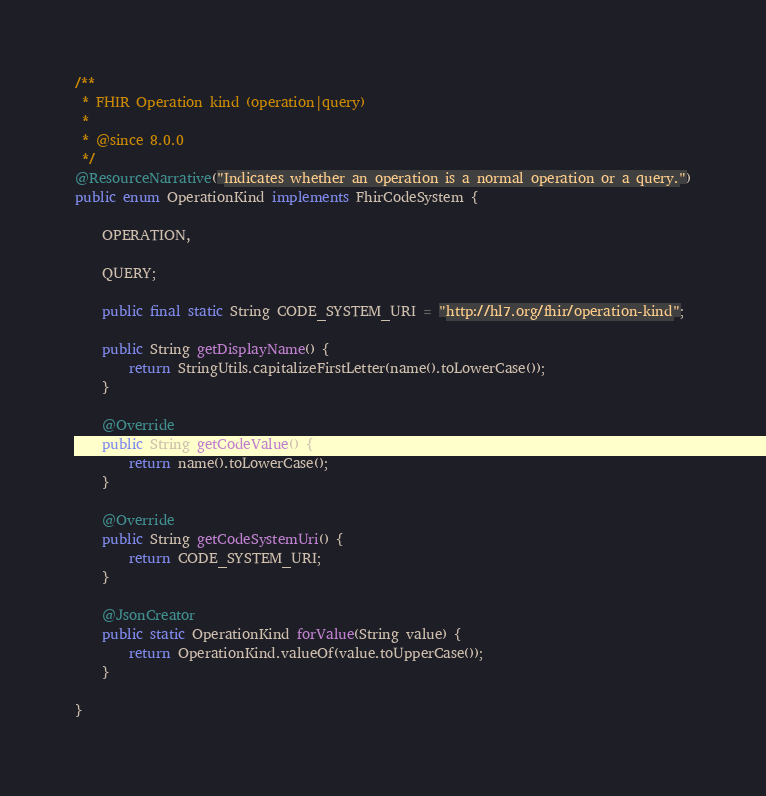Convert code to text. <code><loc_0><loc_0><loc_500><loc_500><_Java_>/**
 * FHIR Operation kind (operation|query)
 * 
 * @since 8.0.0
 */
@ResourceNarrative("Indicates whether an operation is a normal operation or a query.")
public enum OperationKind implements FhirCodeSystem {
	
	OPERATION,
	
	QUERY; 
	
	public final static String CODE_SYSTEM_URI = "http://hl7.org/fhir/operation-kind";
	
	public String getDisplayName() {
		return StringUtils.capitalizeFirstLetter(name().toLowerCase());
	}
	
	@Override
	public String getCodeValue() {
		return name().toLowerCase();
	}
	
	@Override
	public String getCodeSystemUri() {
		return CODE_SYSTEM_URI;
	}
	
	@JsonCreator
    public static OperationKind forValue(String value) {
		return OperationKind.valueOf(value.toUpperCase());
    }

}
</code> 